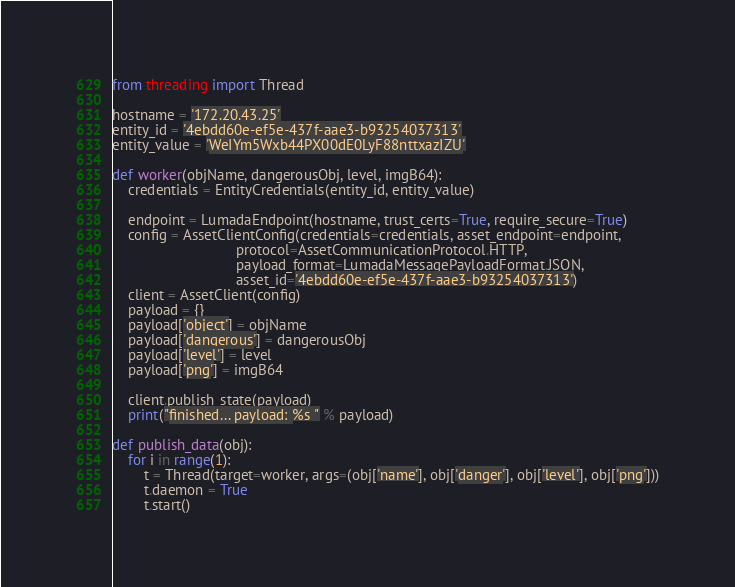Convert code to text. <code><loc_0><loc_0><loc_500><loc_500><_Python_>from threading import Thread

hostname = '172.20.43.25'
entity_id = '4ebdd60e-ef5e-437f-aae3-b93254037313'
entity_value = 'WeIYm5Wxb44PX00dE0LyF88nttxazIZU'

def worker(objName, dangerousObj, level, imgB64):
    credentials = EntityCredentials(entity_id, entity_value)

    endpoint = LumadaEndpoint(hostname, trust_certs=True, require_secure=True)
    config = AssetClientConfig(credentials=credentials, asset_endpoint=endpoint,
                               protocol=AssetCommunicationProtocol.HTTP,
                               payload_format=LumadaMessagePayloadFormat.JSON,
                               asset_id='4ebdd60e-ef5e-437f-aae3-b93254037313')
    client = AssetClient(config)
    payload = {}
    payload['object'] = objName
    payload['dangerous'] = dangerousObj
    payload['level'] = level
    payload['png'] = imgB64

    client.publish_state(payload)
    print("finished... payload: %s " % payload)

def publish_data(obj):
    for i in range(1):
        t = Thread(target=worker, args=(obj['name'], obj['danger'], obj['level'], obj['png']))
        t.daemon = True
        t.start()
</code> 